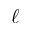<formula> <loc_0><loc_0><loc_500><loc_500>\ell</formula> 